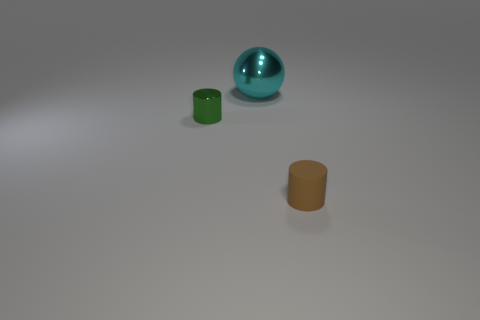There is another tiny object that is the same shape as the rubber object; what is its color?
Offer a terse response. Green. What is the color of the tiny object in front of the small cylinder that is to the left of the sphere to the left of the brown cylinder?
Offer a very short reply. Brown. Is the brown object made of the same material as the tiny green thing?
Your answer should be compact. No. Is the shape of the small metallic thing the same as the small rubber thing?
Give a very brief answer. Yes. Is the number of brown rubber cylinders that are behind the sphere the same as the number of metallic spheres that are in front of the tiny green cylinder?
Provide a short and direct response. Yes. What color is the small object that is made of the same material as the large object?
Offer a terse response. Green. What number of balls have the same material as the small green object?
Provide a short and direct response. 1. There is a cylinder that is behind the tiny brown cylinder; does it have the same color as the rubber cylinder?
Your answer should be very brief. No. What number of other green objects have the same shape as the small green thing?
Provide a succinct answer. 0. Are there the same number of tiny metal cylinders that are behind the tiny shiny thing and yellow balls?
Your answer should be compact. Yes. 